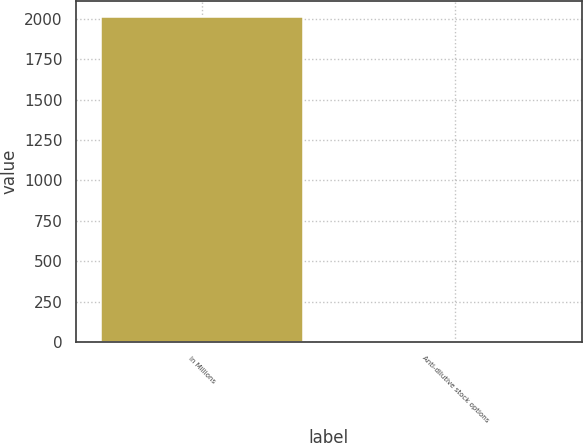<chart> <loc_0><loc_0><loc_500><loc_500><bar_chart><fcel>In Millions<fcel>Anti-dilutive stock options<nl><fcel>2010<fcel>6.3<nl></chart> 